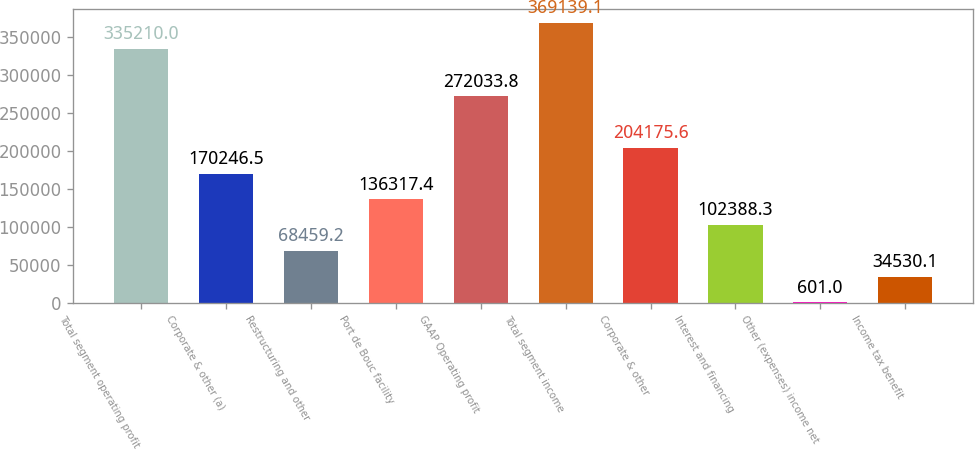Convert chart. <chart><loc_0><loc_0><loc_500><loc_500><bar_chart><fcel>Total segment operating profit<fcel>Corporate & other (a)<fcel>Restructuring and other<fcel>Port de Bouc facility<fcel>GAAP Operating profit<fcel>Total segment income<fcel>Corporate & other<fcel>Interest and financing<fcel>Other (expenses) income net<fcel>Income tax benefit<nl><fcel>335210<fcel>170246<fcel>68459.2<fcel>136317<fcel>272034<fcel>369139<fcel>204176<fcel>102388<fcel>601<fcel>34530.1<nl></chart> 